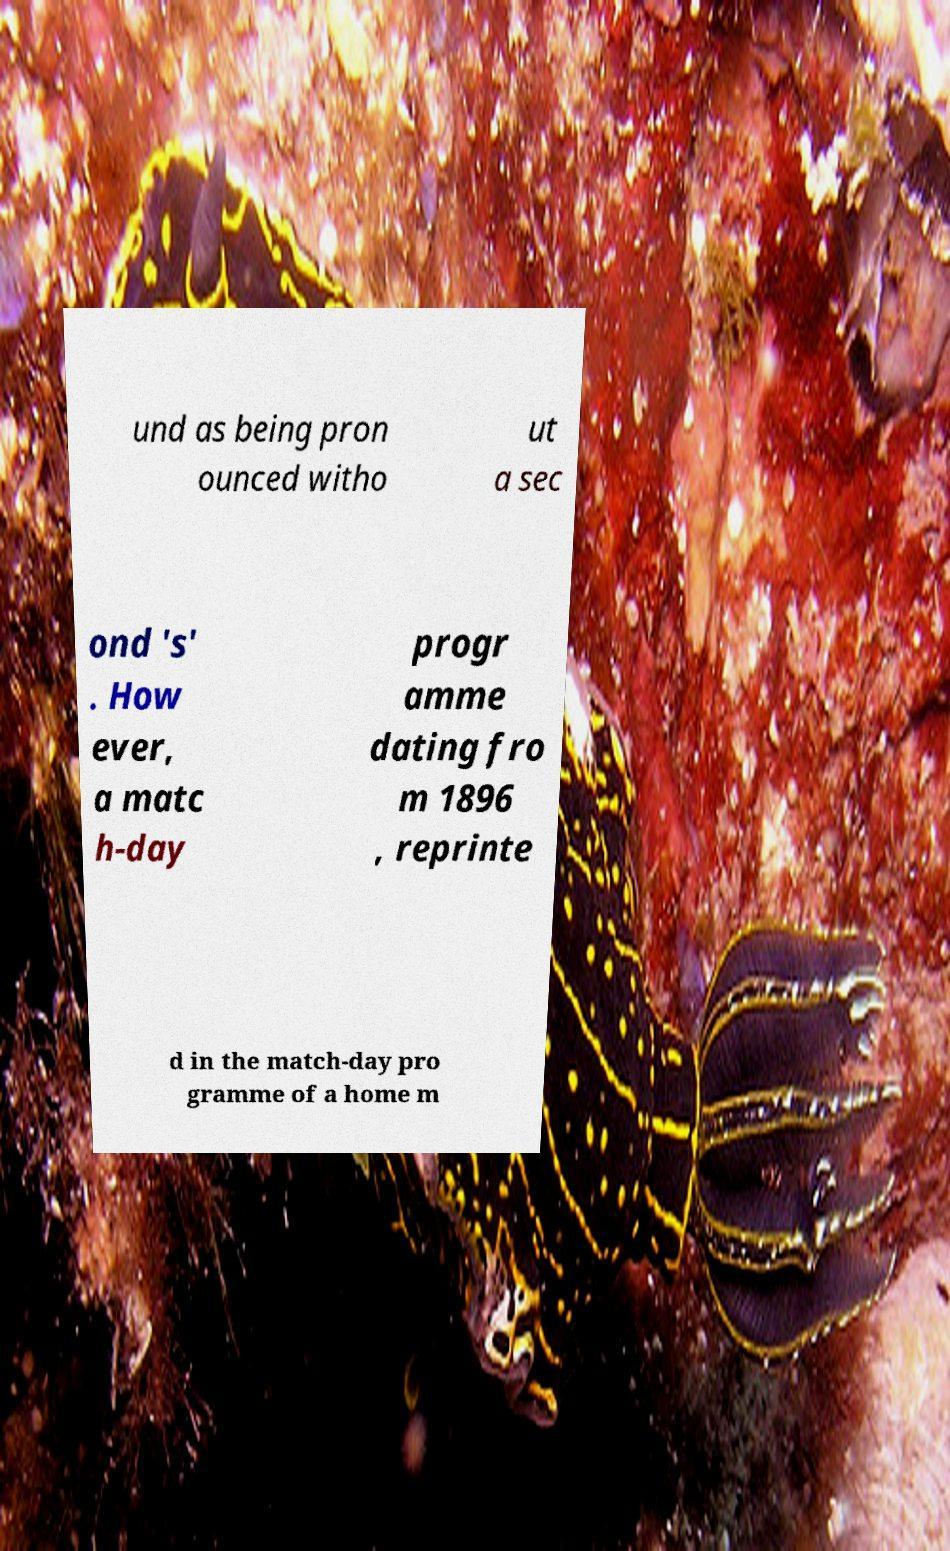There's text embedded in this image that I need extracted. Can you transcribe it verbatim? und as being pron ounced witho ut a sec ond 's' . How ever, a matc h-day progr amme dating fro m 1896 , reprinte d in the match-day pro gramme of a home m 